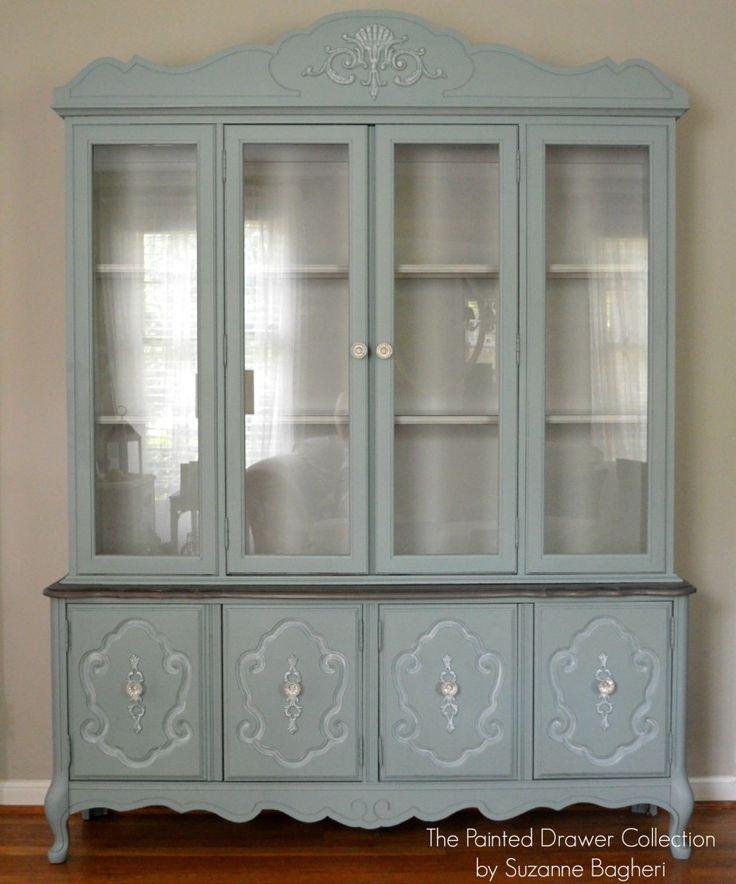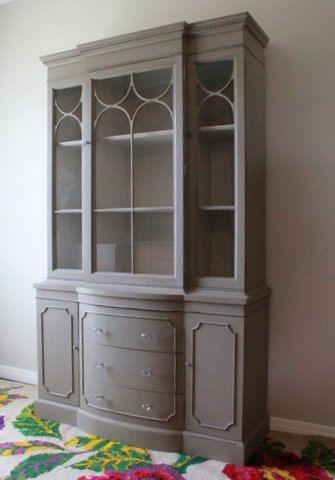The first image is the image on the left, the second image is the image on the right. For the images shown, is this caption "A wooded hutch with a curved top stands on feet, while a second hutch has a straight top and sits flush to the floor." true? Answer yes or no. Yes. The first image is the image on the left, the second image is the image on the right. For the images displayed, is the sentence "One image shows a pale blue shabby chic cabinet with a shaped element on top and a two-handled drawer under the glass doors." factually correct? Answer yes or no. No. 